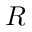<formula> <loc_0><loc_0><loc_500><loc_500>R</formula> 